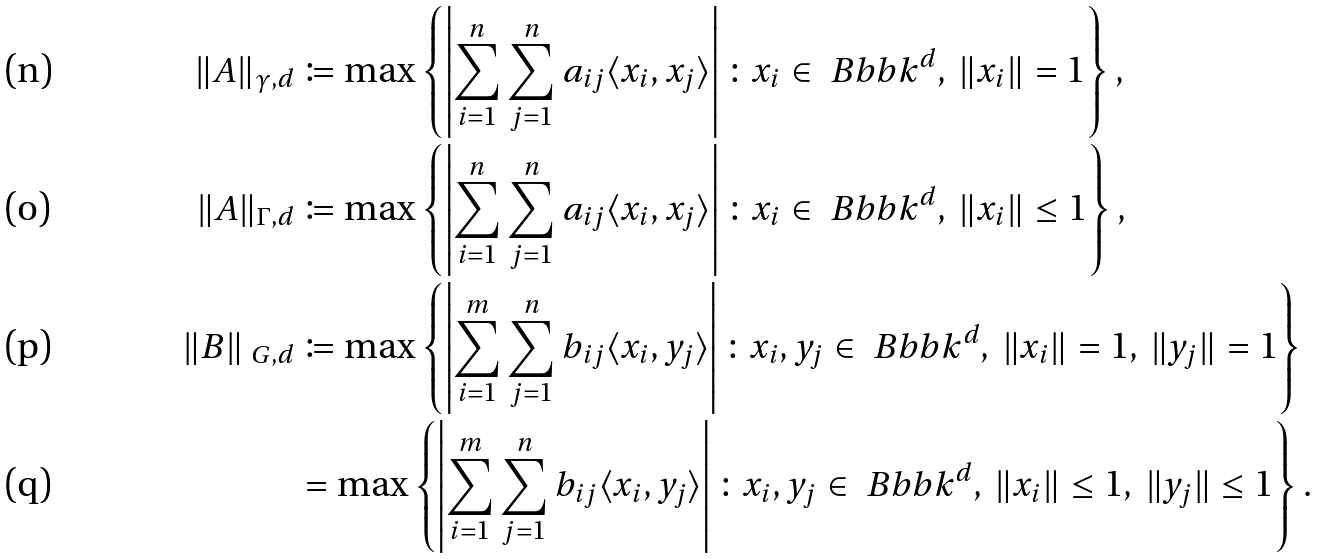Convert formula to latex. <formula><loc_0><loc_0><loc_500><loc_500>\| A \| _ { \gamma , d } & \coloneqq \max \left \{ \left | \sum _ { i = 1 } ^ { n } \sum _ { j = 1 } ^ { n } a _ { i j } \langle x _ { i } , x _ { j } \rangle \right | \colon x _ { i } \in \ B b b k ^ { d } , \, \| x _ { i } \| = 1 \right \} , \\ \| A \| _ { \Gamma , d } & \coloneqq \max \left \{ \left | \sum _ { i = 1 } ^ { n } \sum _ { j = 1 } ^ { n } a _ { i j } \langle x _ { i } , x _ { j } \rangle \right | \colon x _ { i } \in \ B b b k ^ { d } , \, \| x _ { i } \| \leq 1 \right \} , \\ \| B \| _ { \ G , d } & \coloneqq \max \left \{ \left | \sum _ { i = 1 } ^ { m } \sum _ { j = 1 } ^ { n } b _ { i j } \langle x _ { i } , y _ { j } \rangle \right | \colon x _ { i } , y _ { j } \in \ B b b k ^ { d } , \, \| x _ { i } \| = 1 , \, \| y _ { j } \| = 1 \right \} \\ & = \max \left \{ \left | \sum _ { i = 1 } ^ { m } \sum _ { j = 1 } ^ { n } b _ { i j } \langle x _ { i } , y _ { j } \rangle \right | \colon x _ { i } , y _ { j } \in \ B b b k ^ { d } , \, \| x _ { i } \| \leq 1 , \, \| y _ { j } \| \leq 1 \right \} .</formula> 